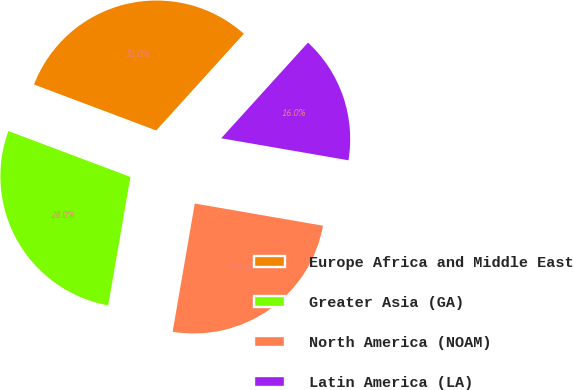<chart> <loc_0><loc_0><loc_500><loc_500><pie_chart><fcel>Europe Africa and Middle East<fcel>Greater Asia (GA)<fcel>North America (NOAM)<fcel>Latin America (LA)<nl><fcel>31.0%<fcel>28.0%<fcel>25.0%<fcel>16.0%<nl></chart> 